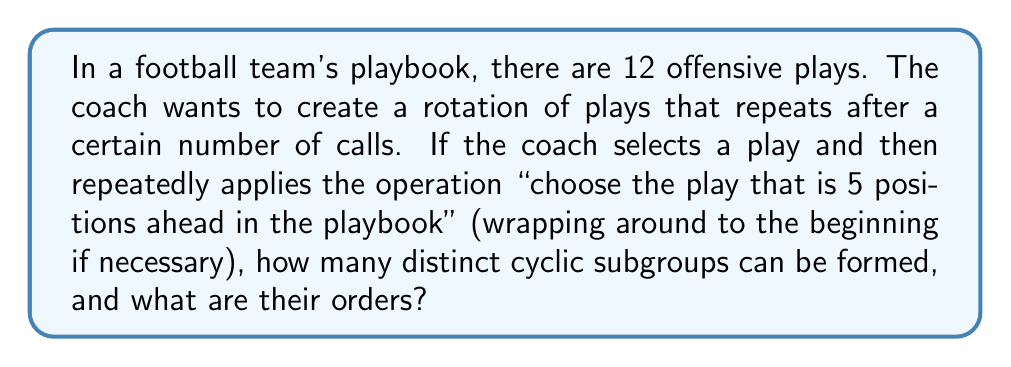Can you answer this question? Let's approach this step-by-step:

1) First, we need to understand what this operation means in terms of group theory. We have a set of 12 elements (plays), and we're applying a transformation that moves us 5 steps forward each time. This is equivalent to addition modulo 12.

2) In group theory terms, we're looking at the cyclic subgroups generated by the element 5 in the group $(\mathbb{Z}_{12}, +)$.

3) To find the cyclic subgroups, we need to repeatedly add 5 (mod 12) until we get back to 0:

   $5 \equiv 5 \pmod{12}$
   $5 + 5 \equiv 10 \pmod{12}$
   $10 + 5 \equiv 3 \pmod{12}$
   $3 + 5 \equiv 8 \pmod{12}$
   $8 + 5 \equiv 1 \pmod{12}$
   $1 + 5 \equiv 6 \pmod{12}$
   $6 + 5 \equiv 11 \pmod{12}$
   $11 + 5 \equiv 4 \pmod{12}$
   $4 + 5 \equiv 9 \pmod{12}$
   $9 + 5 \equiv 2 \pmod{12}$
   $2 + 5 \equiv 7 \pmod{12}$
   $7 + 5 \equiv 0 \pmod{12}$

4) We see that we go through all 12 elements before returning to 0. This means that the element 5 generates the entire group $\mathbb{Z}_{12}$.

5) In group theory, we know that the subgroups of a cyclic group are precisely the groups generated by its powers. The powers of 5 in $\mathbb{Z}_{12}$ are:

   $5^1 \equiv 5 \pmod{12}$
   $5^2 \equiv 1 \pmod{12}$
   $5^3 \equiv 5 \pmod{12}$
   $5^4 \equiv 1 \pmod{12}$

6) This means we have two distinct generators: 5 and 1.

7) The subgroup generated by 5 is the entire group, of order 12.
   The subgroup generated by 1 is $\{0, 1, 2, 3, 4, 5, 6, 7, 8, 9, 10, 11\}$, also of order 12.

Therefore, there is only one distinct cyclic subgroup in this case, and its order is 12.
Answer: There is 1 distinct cyclic subgroup, with order 12. 